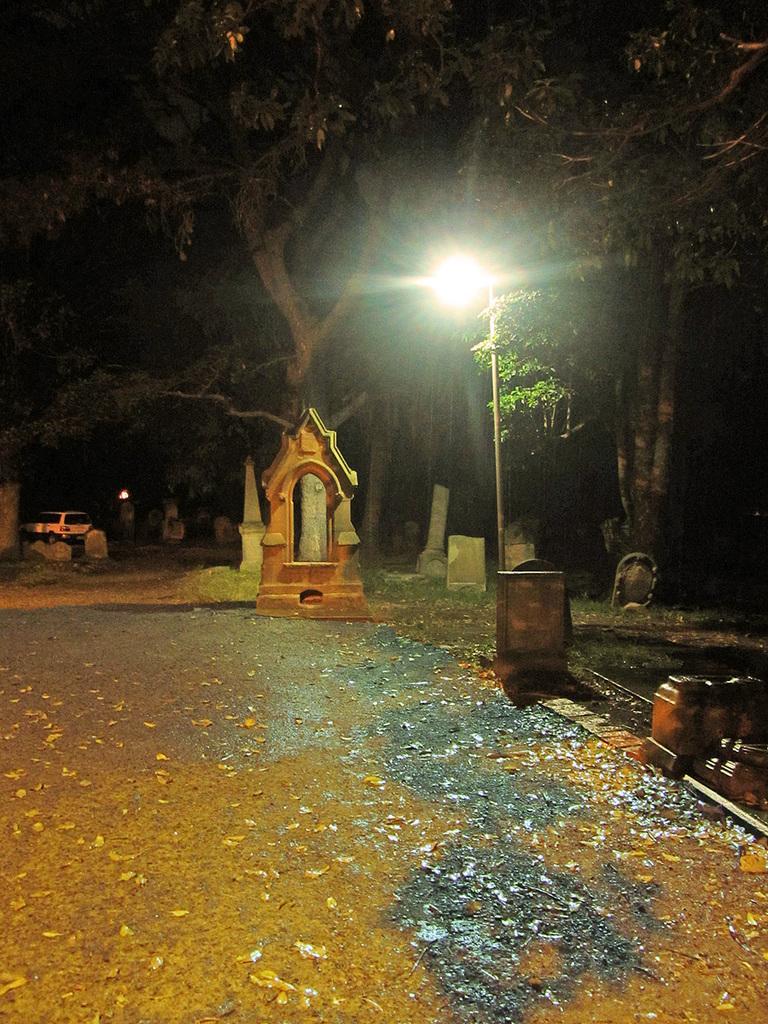Describe this image in one or two sentences. In this image we can see a statue. To the right side of the image we can see a light pole. In the background , we can see group of trees and a vehicle parked on the ground. 